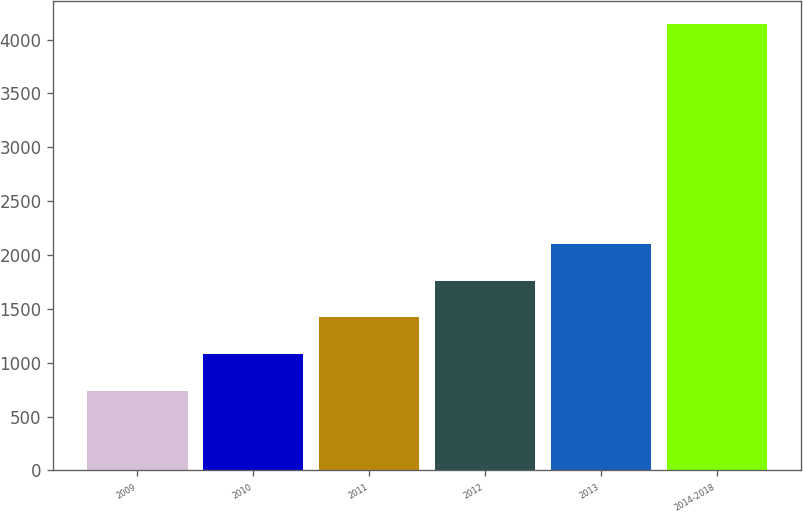Convert chart. <chart><loc_0><loc_0><loc_500><loc_500><bar_chart><fcel>2009<fcel>2010<fcel>2011<fcel>2012<fcel>2013<fcel>2014-2018<nl><fcel>740<fcel>1080.8<fcel>1421.6<fcel>1762.4<fcel>2103.2<fcel>4148<nl></chart> 